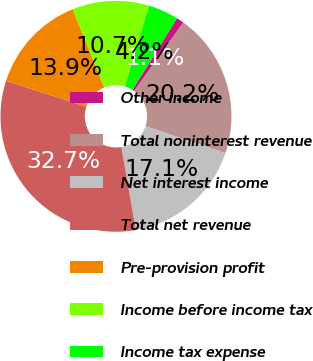Convert chart. <chart><loc_0><loc_0><loc_500><loc_500><pie_chart><fcel>Other income<fcel>Total noninterest revenue<fcel>Net interest income<fcel>Total net revenue<fcel>Pre-provision profit<fcel>Income before income tax<fcel>Income tax expense<nl><fcel>1.06%<fcel>20.25%<fcel>17.08%<fcel>32.73%<fcel>13.91%<fcel>10.74%<fcel>4.23%<nl></chart> 